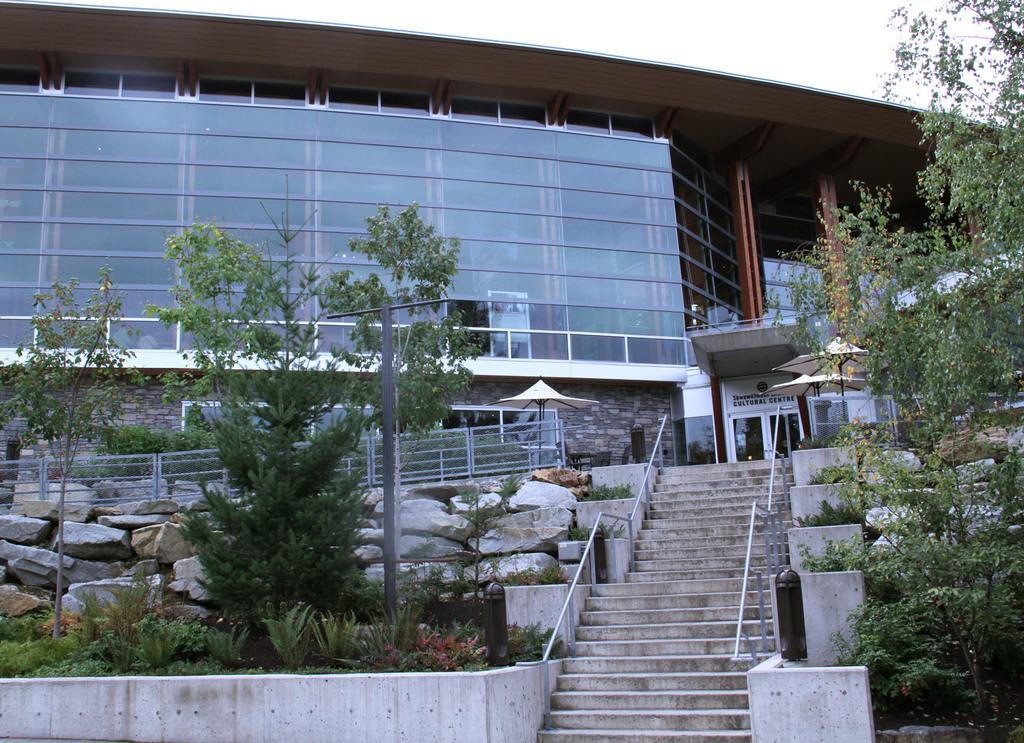What is the main structure in the center of the image? There is a building in the center of the image. Can you describe any specific features of the building? There is a door in the image, which is a feature of the building. What type of temporary shelters can be seen in the image? There are tents in the image. What type of barrier is present in the image? There is fencing in the image. Are there any architectural elements that allow for vertical movement? Yes, there are stairs in the image. What type of natural elements can be seen in the image? There are rocks and trees in the image. What is the tall, thin object in the image? There is a pole in the image. What is visible at the top of the image? The sky is visible at the top of the image. How many birds are perched on the feather in the image? There are no birds or feathers present in the image. What type of room is visible in the image? There is no room visible in the image; it features an outdoor scene with a building, tents, fencing, stairs, rocks, trees, and a pole. 